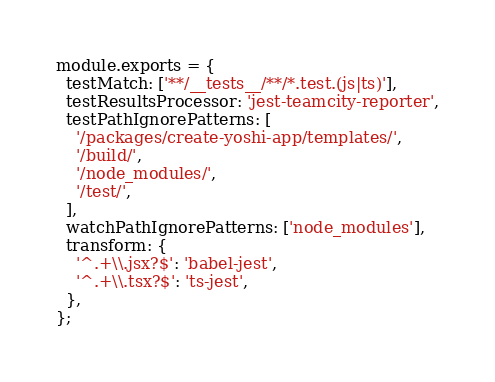<code> <loc_0><loc_0><loc_500><loc_500><_JavaScript_>module.exports = {
  testMatch: ['**/__tests__/**/*.test.(js|ts)'],
  testResultsProcessor: 'jest-teamcity-reporter',
  testPathIgnorePatterns: [
    '/packages/create-yoshi-app/templates/',
    '/build/',
    '/node_modules/',
    '/test/',
  ],
  watchPathIgnorePatterns: ['node_modules'],
  transform: {
    '^.+\\.jsx?$': 'babel-jest',
    '^.+\\.tsx?$': 'ts-jest',
  },
};
</code> 